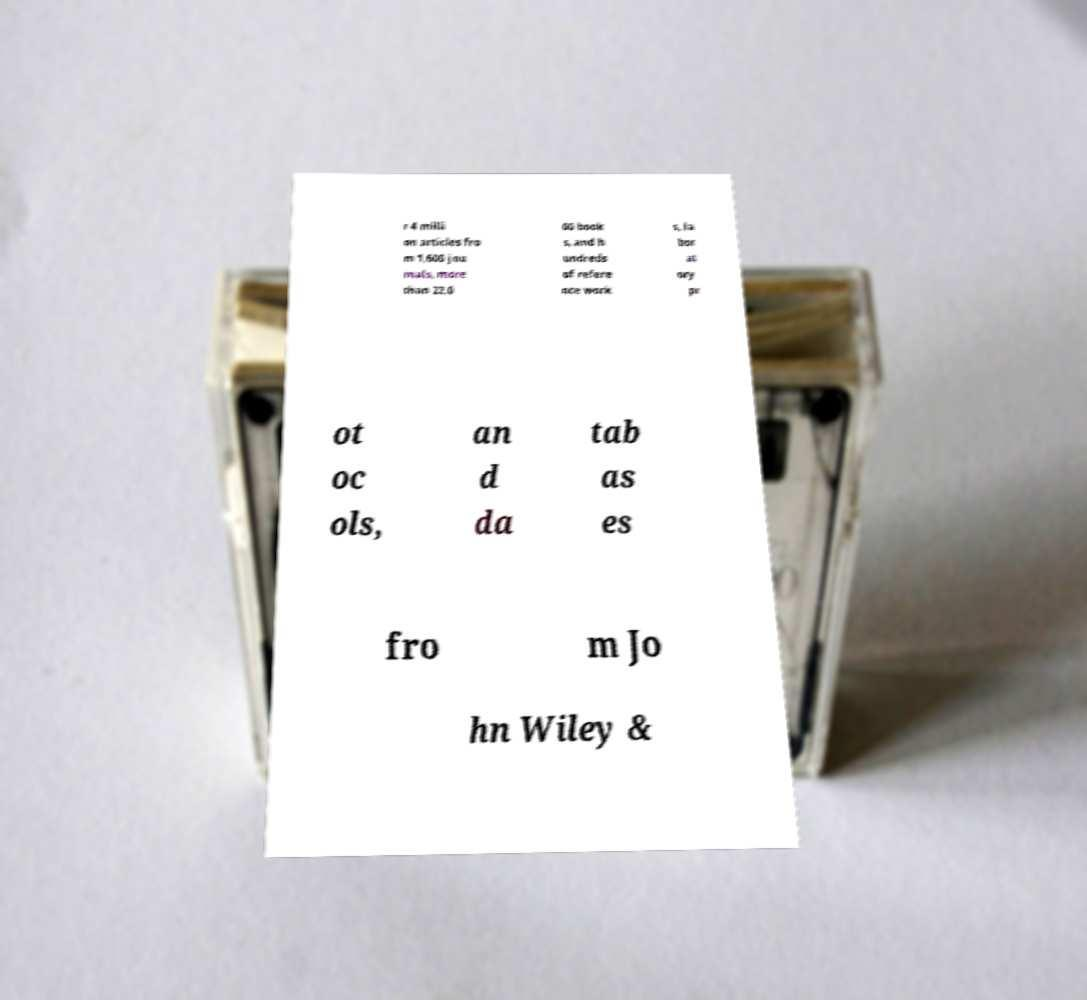Can you read and provide the text displayed in the image?This photo seems to have some interesting text. Can you extract and type it out for me? r 4 milli on articles fro m 1,600 jou rnals, more than 22,0 00 book s, and h undreds of refere nce work s, la bor at ory pr ot oc ols, an d da tab as es fro m Jo hn Wiley & 